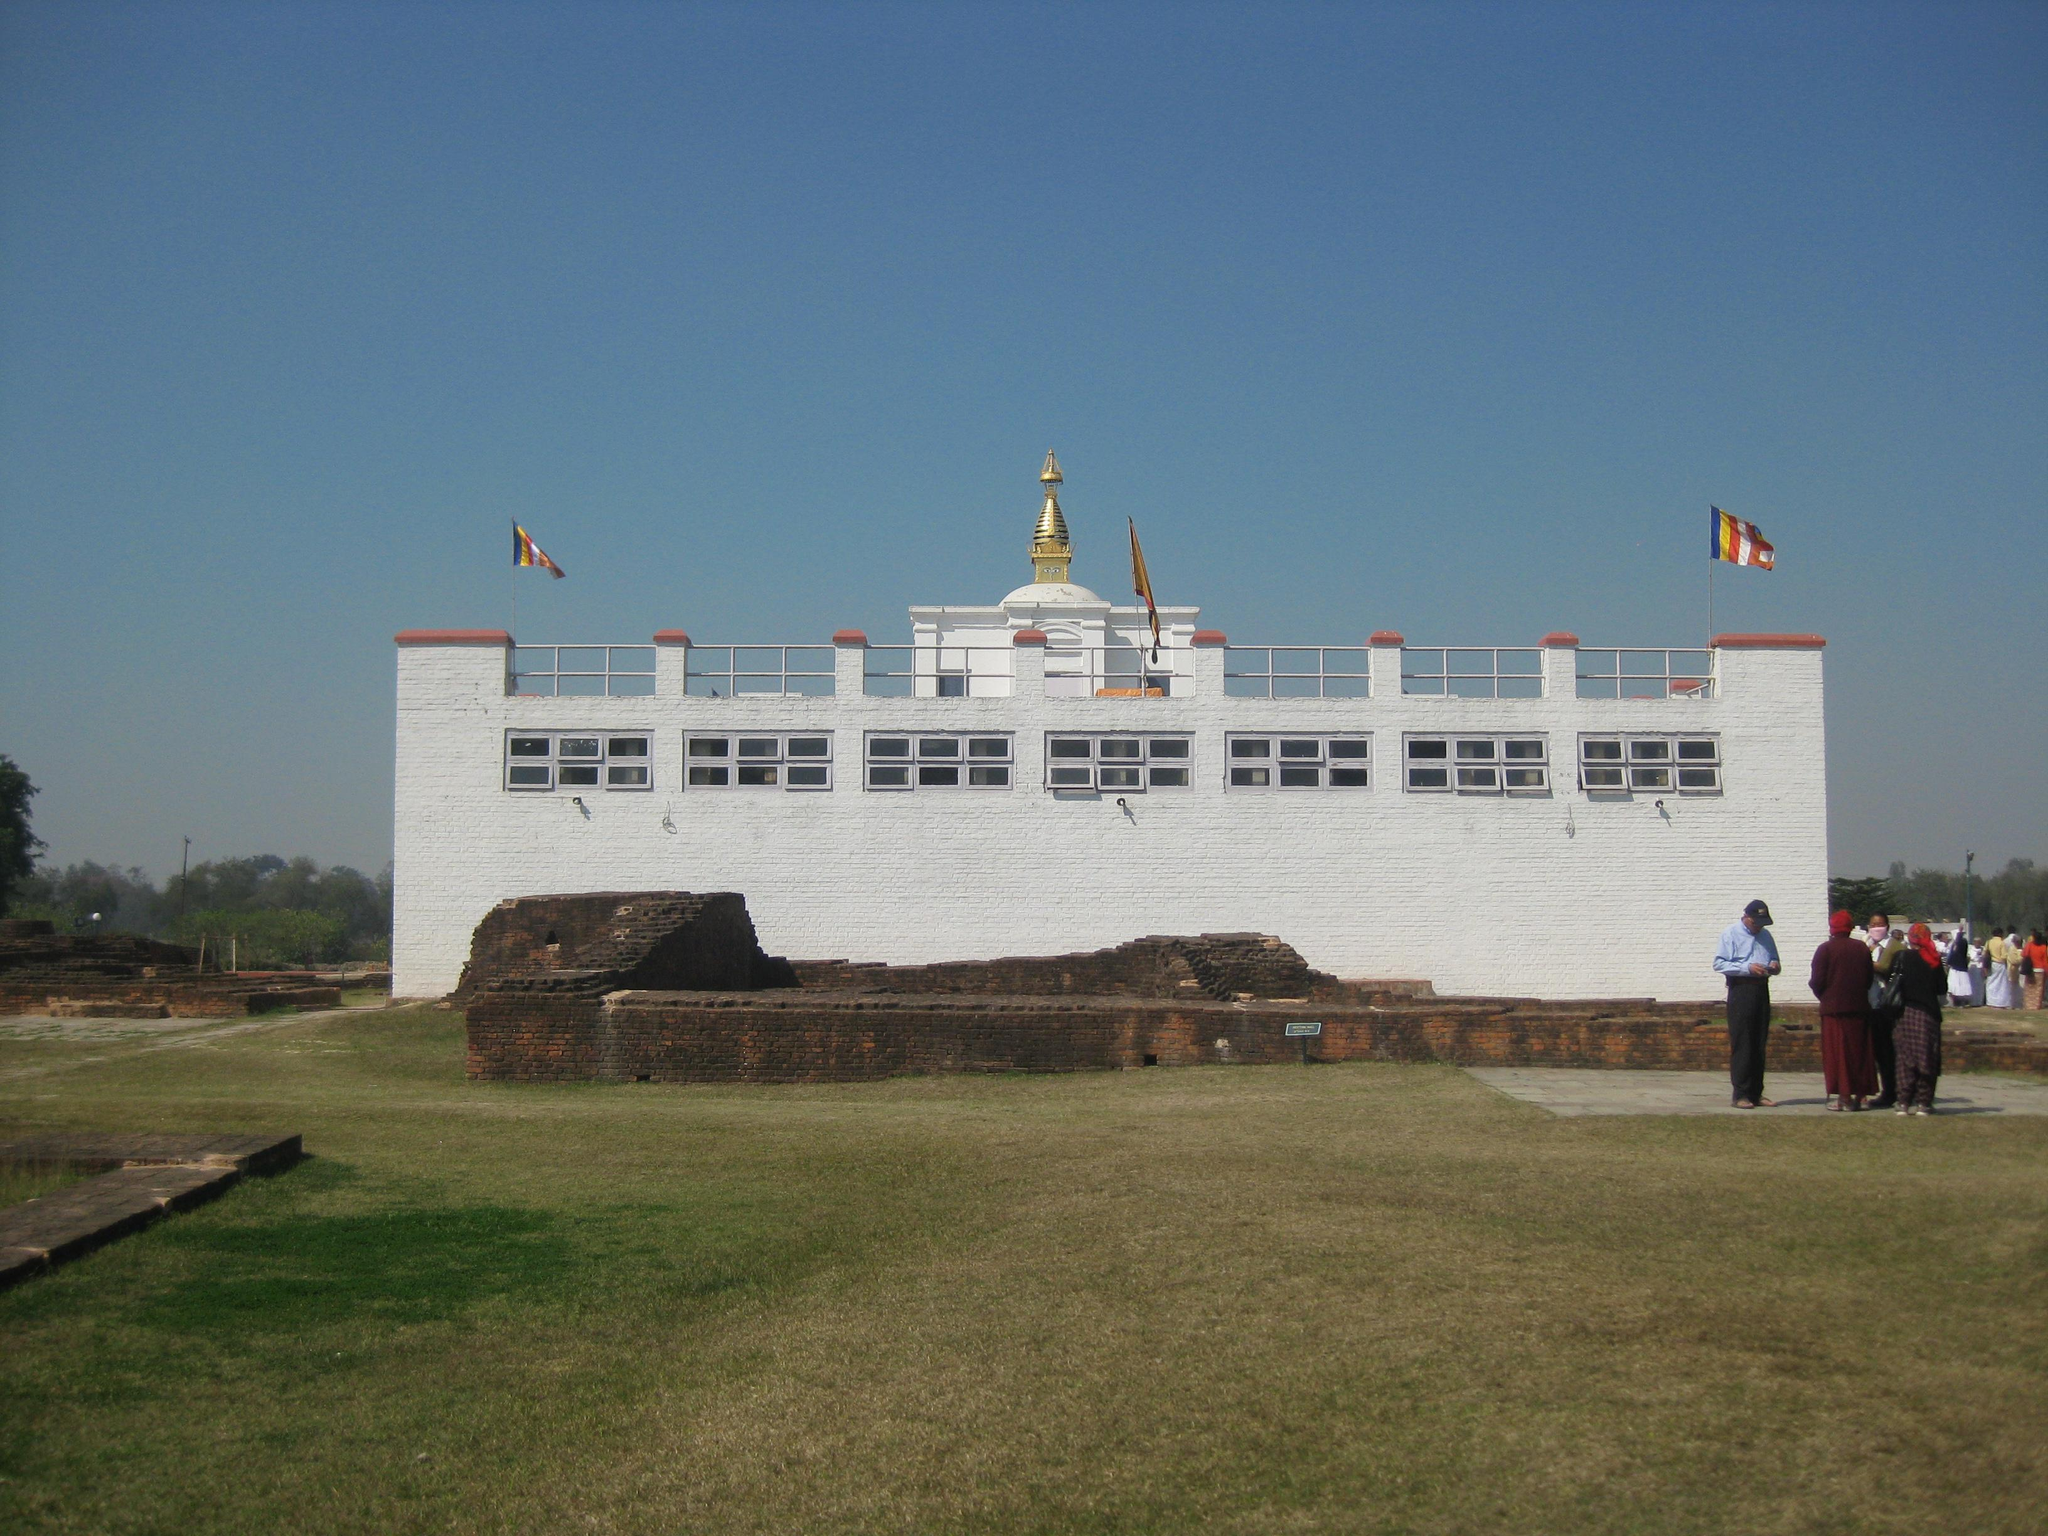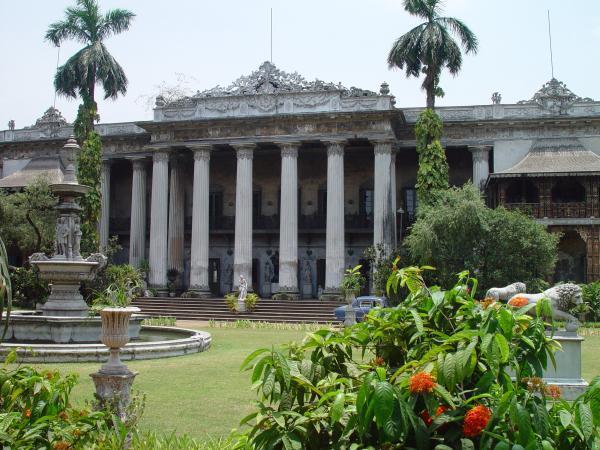The first image is the image on the left, the second image is the image on the right. Analyze the images presented: Is the assertion "At least one flag is waving at the site of one building." valid? Answer yes or no. Yes. The first image is the image on the left, the second image is the image on the right. Analyze the images presented: Is the assertion "An image shows a tall cone-shaped structure flanked by smaller similarly shaped structures." valid? Answer yes or no. No. 